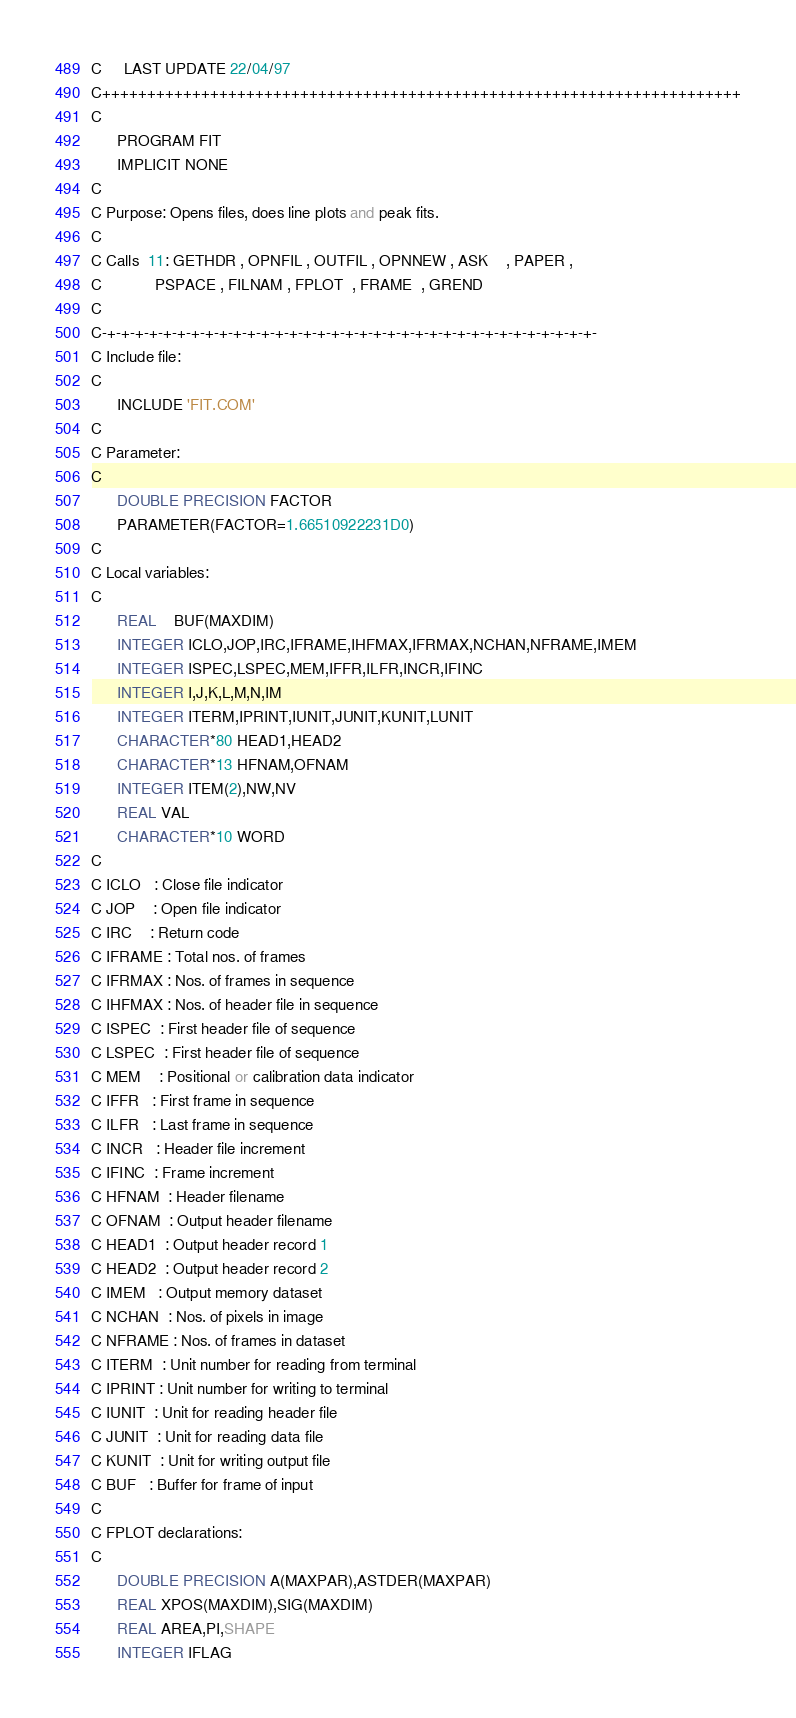Convert code to text. <code><loc_0><loc_0><loc_500><loc_500><_FORTRAN_>C     LAST UPDATE 22/04/97
C+++++++++++++++++++++++++++++++++++++++++++++++++++++++++++++++++++++++
C
      PROGRAM FIT
      IMPLICIT NONE
C
C Purpose: Opens files, does line plots and peak fits.
C
C Calls  11: GETHDR , OPNFIL , OUTFIL , OPNNEW , ASK    , PAPER ,
C            PSPACE , FILNAM , FPLOT  , FRAME  , GREND 
C
C-+-+-+-+-+-+-+-+-+-+-+-+-+-+-+-+-+-+-+-+-+-+-+-+-+-+-+-+-+-+-+-+-+-+-+-
C Include file:
C
      INCLUDE 'FIT.COM'
C
C Parameter:
C
      DOUBLE PRECISION FACTOR
      PARAMETER(FACTOR=1.66510922231D0)
C
C Local variables:
C
      REAL    BUF(MAXDIM)
      INTEGER ICLO,JOP,IRC,IFRAME,IHFMAX,IFRMAX,NCHAN,NFRAME,IMEM
      INTEGER ISPEC,LSPEC,MEM,IFFR,ILFR,INCR,IFINC
      INTEGER I,J,K,L,M,N,IM
      INTEGER ITERM,IPRINT,IUNIT,JUNIT,KUNIT,LUNIT
      CHARACTER*80 HEAD1,HEAD2
      CHARACTER*13 HFNAM,OFNAM
      INTEGER ITEM(2),NW,NV
      REAL VAL
      CHARACTER*10 WORD
C
C ICLO   : Close file indicator
C JOP    : Open file indicator
C IRC    : Return code
C IFRAME : Total nos. of frames
C IFRMAX : Nos. of frames in sequence
C IHFMAX : Nos. of header file in sequence
C ISPEC  : First header file of sequence
C LSPEC  : First header file of sequence
C MEM    : Positional or calibration data indicator
C IFFR   : First frame in sequence
C ILFR   : Last frame in sequence
C INCR   : Header file increment
C IFINC  : Frame increment
C HFNAM  : Header filename
C OFNAM  : Output header filename 
C HEAD1  : Output header record 1
C HEAD2  : Output header record 2
C IMEM   : Output memory dataset
C NCHAN  : Nos. of pixels in image
C NFRAME : Nos. of frames in dataset
C ITERM  : Unit number for reading from terminal
C IPRINT : Unit number for writing to terminal
C IUNIT  : Unit for reading header file
C JUNIT  : Unit for reading data file
C KUNIT  : Unit for writing output file
C BUF   : Buffer for frame of input     
C
C FPLOT declarations:
C
      DOUBLE PRECISION A(MAXPAR),ASTDER(MAXPAR)
      REAL XPOS(MAXDIM),SIG(MAXDIM)
      REAL AREA,PI,SHAPE
      INTEGER IFLAG</code> 